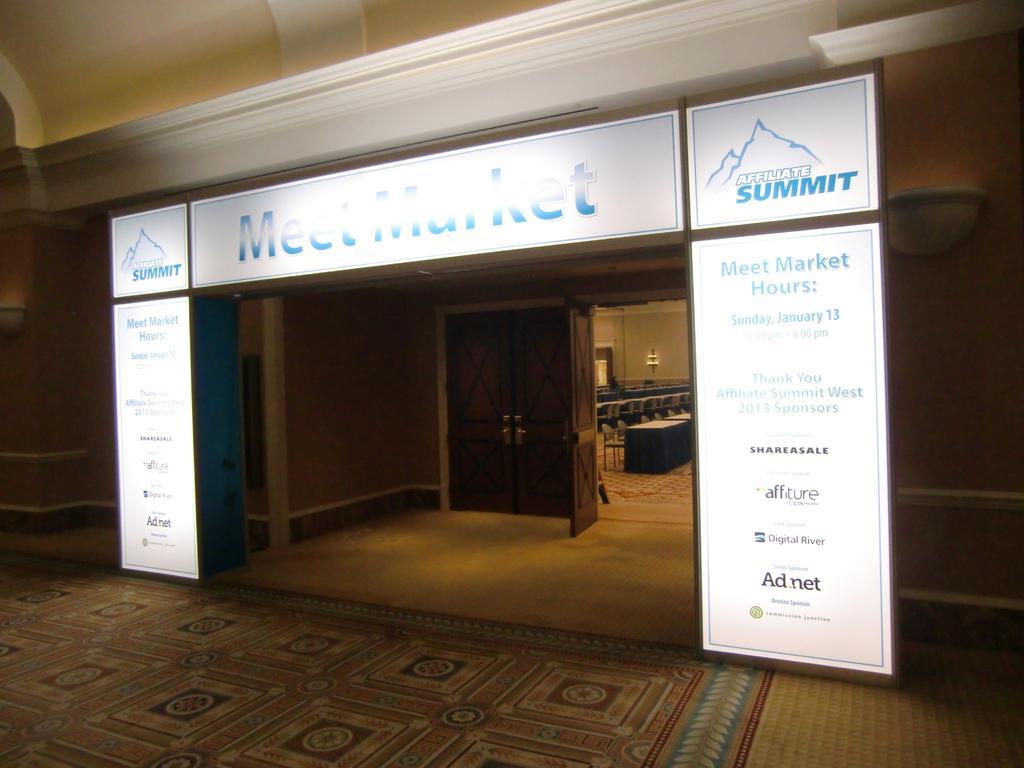Please provide a concise description of this image. In the foreground of this picture we can see a floor carpet and we can see the text on the banners attached to the wall. In the background we can see the wall, doors, chairs, tables and some other objects. 